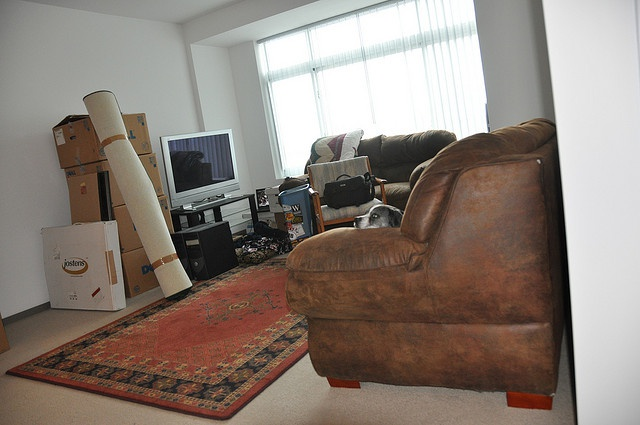Describe the objects in this image and their specific colors. I can see chair in gray, maroon, black, and brown tones, couch in gray, maroon, black, and brown tones, couch in gray, black, darkgray, and white tones, tv in gray, black, darkgray, and lightgray tones, and chair in gray, black, and maroon tones in this image. 